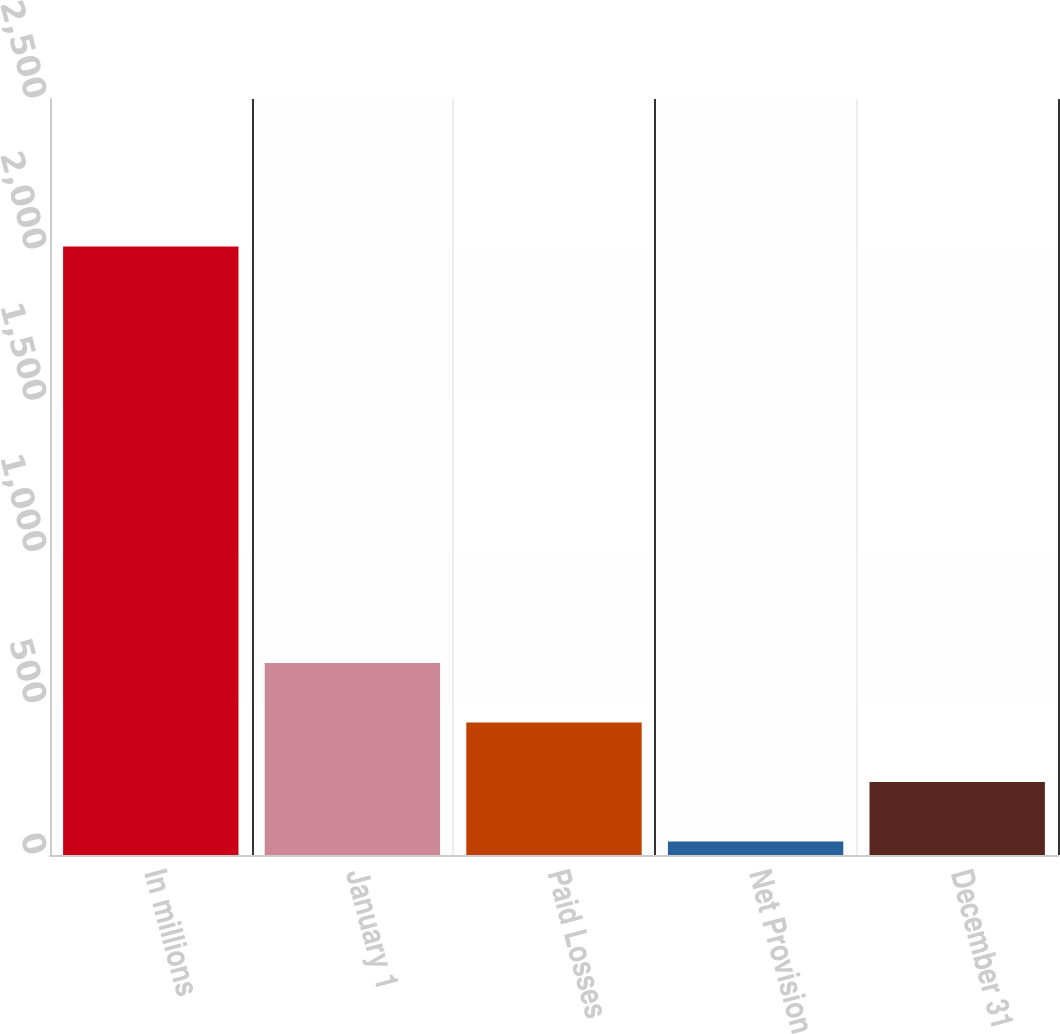Convert chart to OTSL. <chart><loc_0><loc_0><loc_500><loc_500><bar_chart><fcel>In millions<fcel>January 1<fcel>Paid Losses<fcel>Net Provision<fcel>December 31<nl><fcel>2012<fcel>635.1<fcel>438.4<fcel>45<fcel>241.7<nl></chart> 